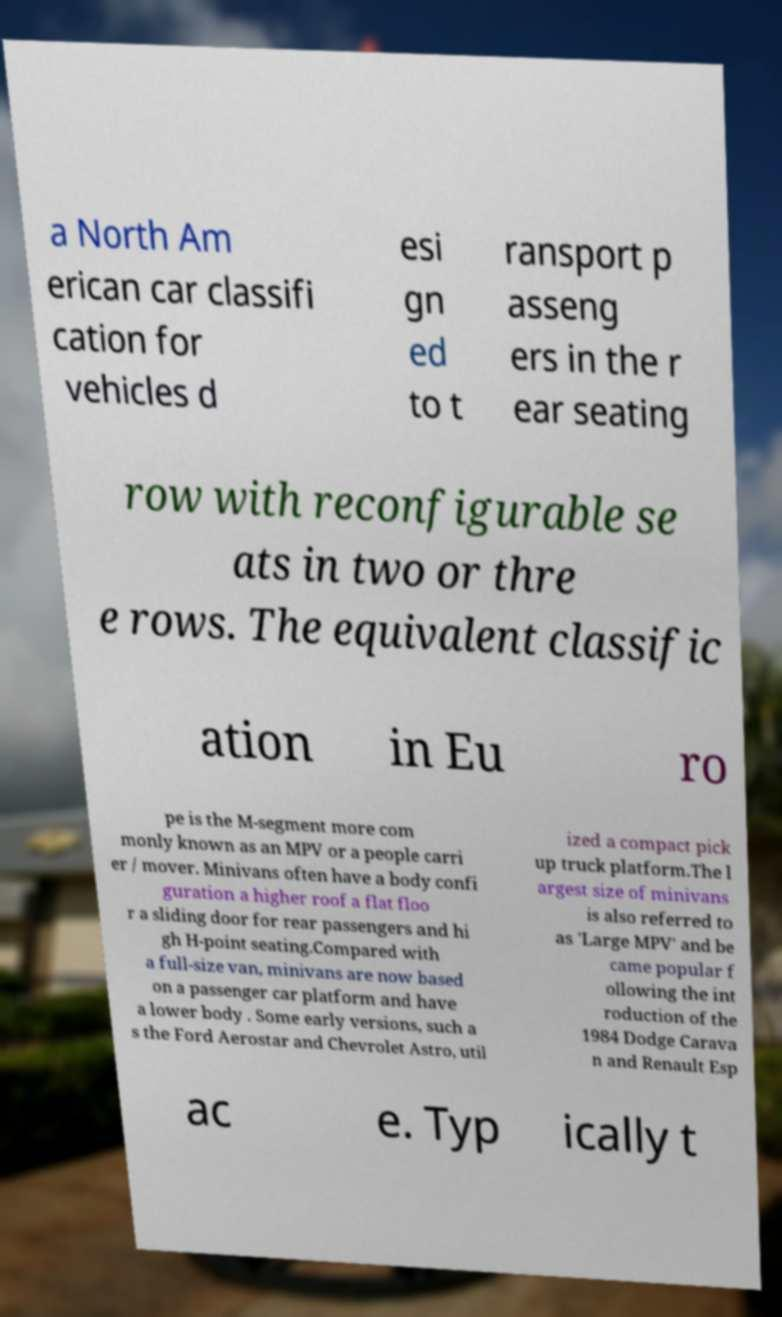Could you assist in decoding the text presented in this image and type it out clearly? a North Am erican car classifi cation for vehicles d esi gn ed to t ransport p asseng ers in the r ear seating row with reconfigurable se ats in two or thre e rows. The equivalent classific ation in Eu ro pe is the M-segment more com monly known as an MPV or a people carri er / mover. Minivans often have a body confi guration a higher roof a flat floo r a sliding door for rear passengers and hi gh H-point seating.Compared with a full-size van, minivans are now based on a passenger car platform and have a lower body . Some early versions, such a s the Ford Aerostar and Chevrolet Astro, util ized a compact pick up truck platform.The l argest size of minivans is also referred to as 'Large MPV' and be came popular f ollowing the int roduction of the 1984 Dodge Carava n and Renault Esp ac e. Typ ically t 